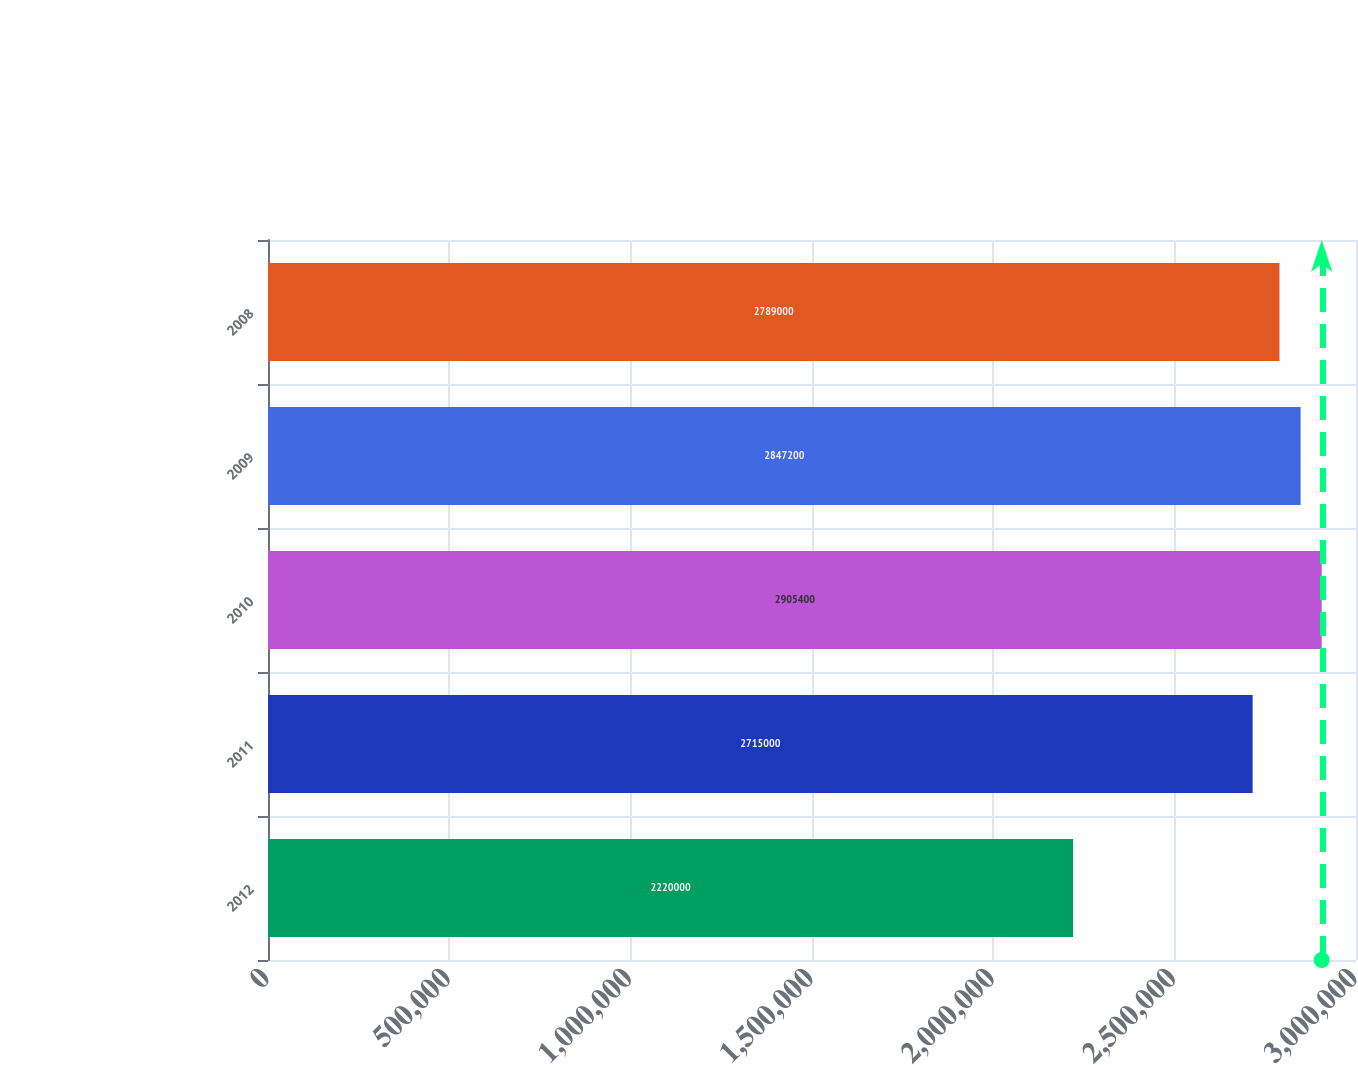Convert chart. <chart><loc_0><loc_0><loc_500><loc_500><bar_chart><fcel>2012<fcel>2011<fcel>2010<fcel>2009<fcel>2008<nl><fcel>2.22e+06<fcel>2.715e+06<fcel>2.9054e+06<fcel>2.8472e+06<fcel>2.789e+06<nl></chart> 